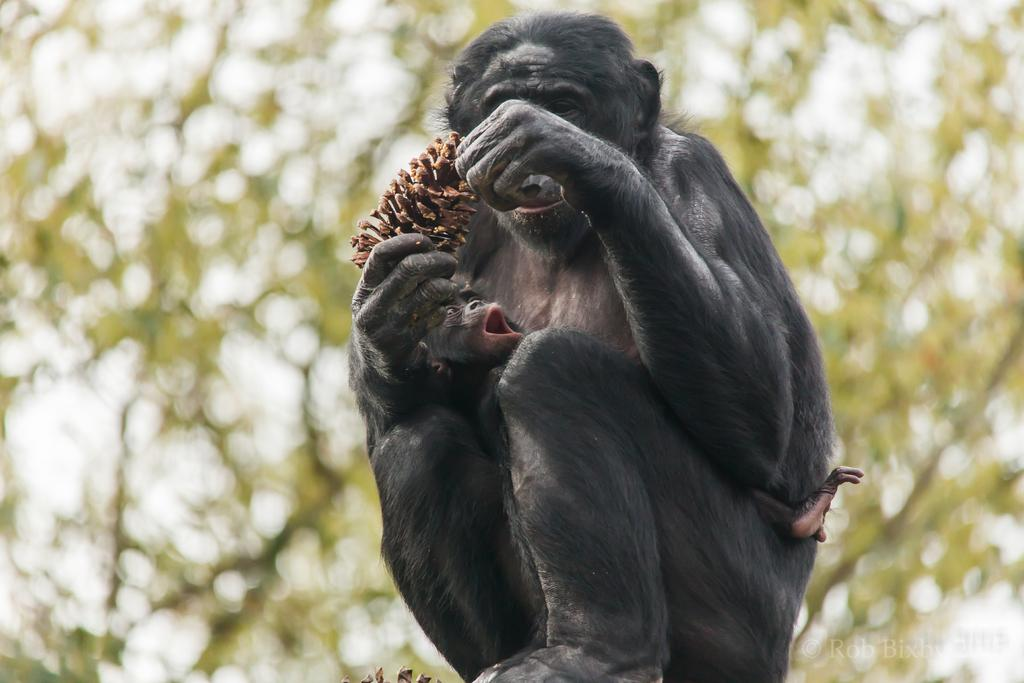What animals are present in the image? There are monkeys in the image. What are the monkeys holding in the image? The monkeys are holding an object. What can be seen in the background of the image? There are trees in the background of the image. What type of seat can be seen in the image? There is no seat present in the image. What action is the secretary performing in the image? There is no secretary present in the image. 